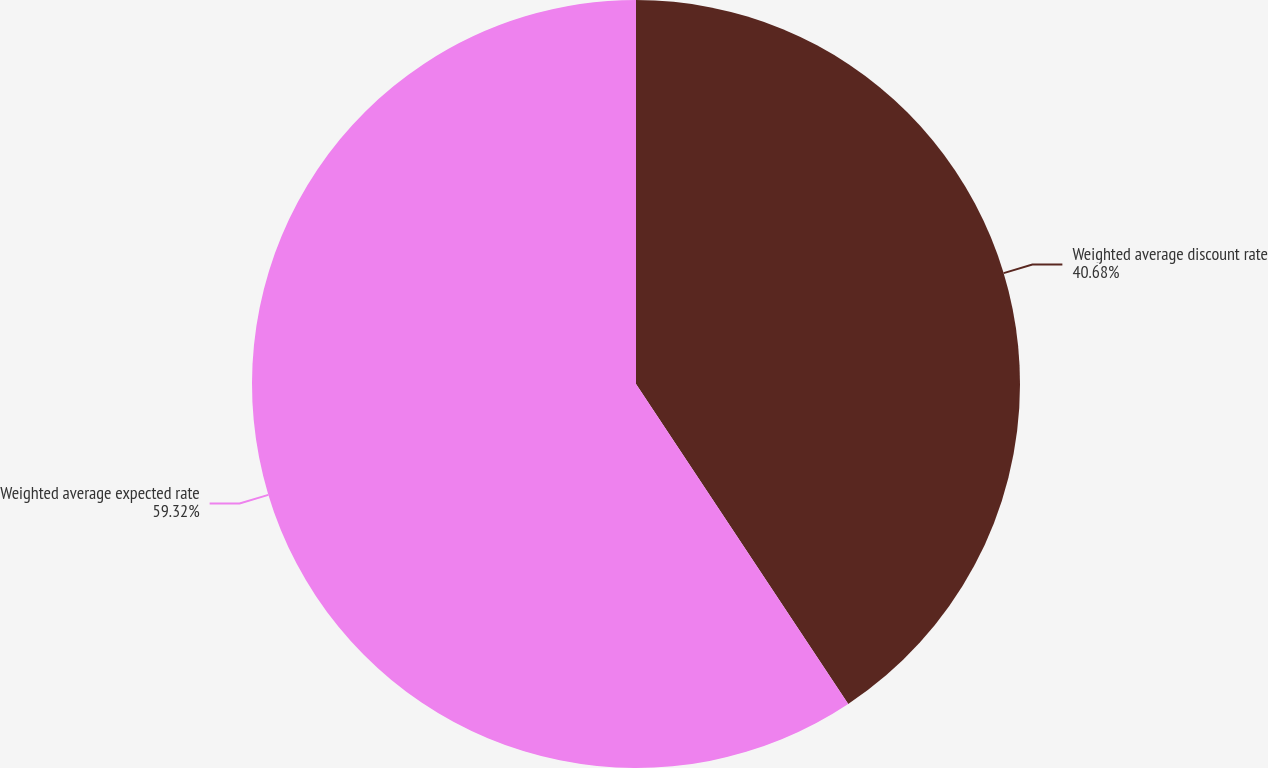Convert chart to OTSL. <chart><loc_0><loc_0><loc_500><loc_500><pie_chart><fcel>Weighted average discount rate<fcel>Weighted average expected rate<nl><fcel>40.68%<fcel>59.32%<nl></chart> 